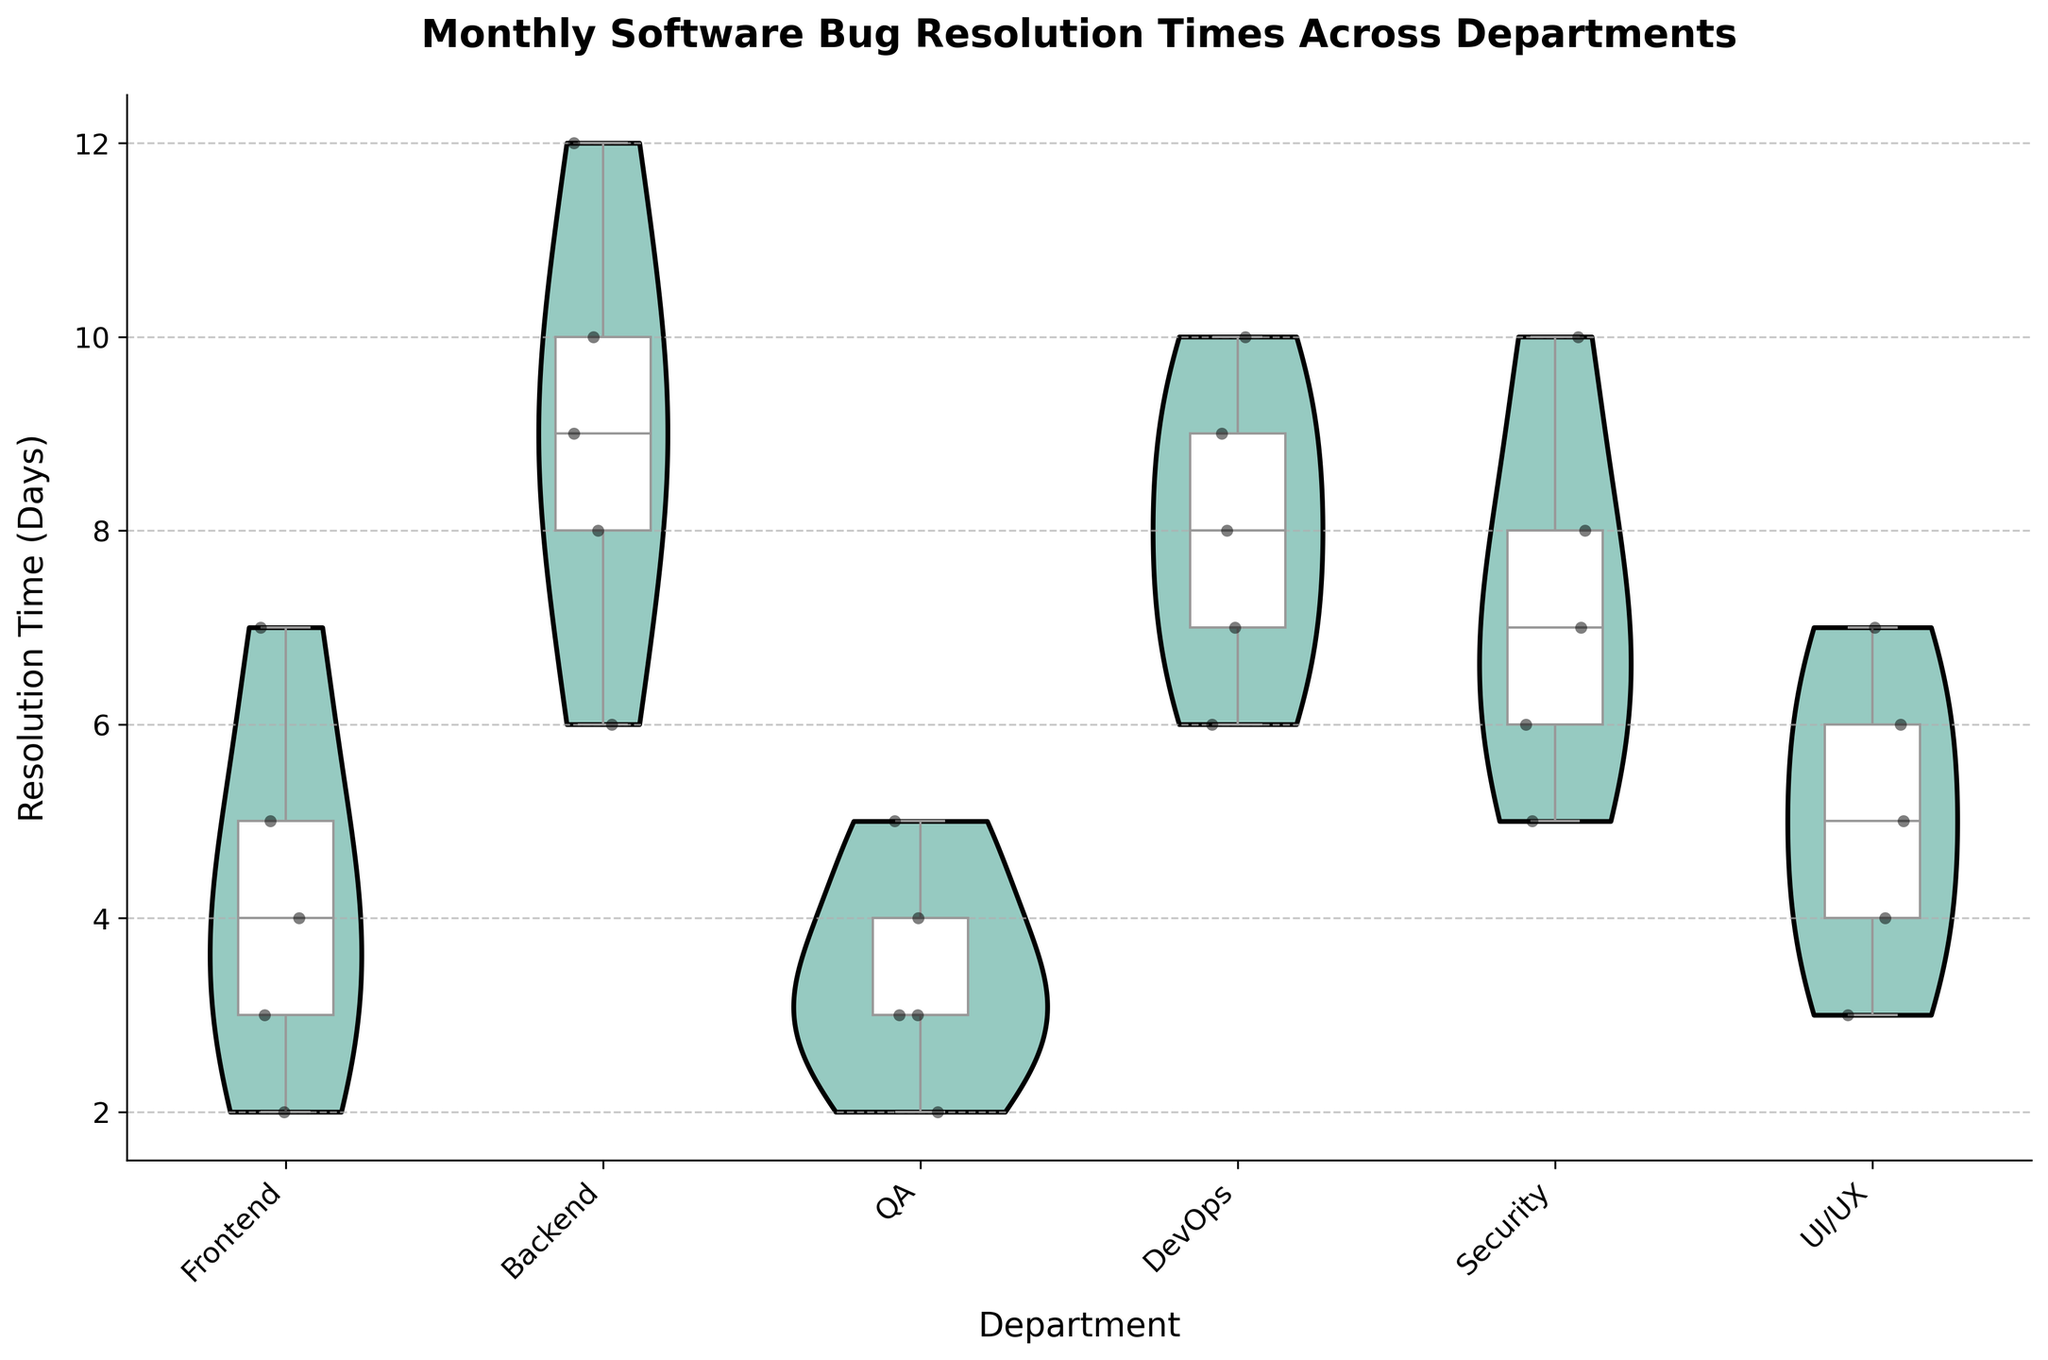How many departments are included in the figure? Count the number of distinct categories on the x-axis. There are "Frontend", "Backend", "QA", "DevOps", "Security", and "UI/UX".
Answer: 6 What is the title of the figure? Look at the text at the top center of the figure. It reads, "Monthly Software Bug Resolution Times Across Departments".
Answer: Monthly Software Bug Resolution Times Across Departments Which department has the highest median resolution time? Check the middle line of the white box in each violin plot. The "Backend" department has the highest median line.
Answer: Backend Which department has the lowest variability in resolution times? Look for the department with the smallest spread in its violin plot. The "QA" department has the narrowest distribution.
Answer: QA What is the median resolution time for the Security department? Find the white box plot color in "Security" department, and identify the middle line of this box, it is at 7 days.
Answer: 7 days How does the median resolution time for Frontend compare to QA? Compare the white box plot medians of "Frontend" and "QA". "Frontend" has a higher median line than "QA".
Answer: Frontend median is higher What is the range of resolution times for DevOps? Look at the highest and lowest points of the violin plot for "DevOps". The highest point is 10 days, and the lowest is 6 days.
Answer: 4 days What does the distribution of resolution times reveal about the Backend department? The Backend has a wide, evenly distributed violin plot, indicating varied resolution times from 6 to 12 days with a central tendency around 8 to 10 days.
Answer: Varied resolution times Which department shows a bimodal distribution in resolution times? Look for a violin plot that has two peaks. The "Frontend" department shows a slight bimodal distribution.
Answer: Frontend For the UI/UX department, are there any outliers in resolution time? Check for any dots outside the interquartile range in the box plot for "UI/UX". There are no dots beyond the whiskers, hence, no outliers.
Answer: No outliers 